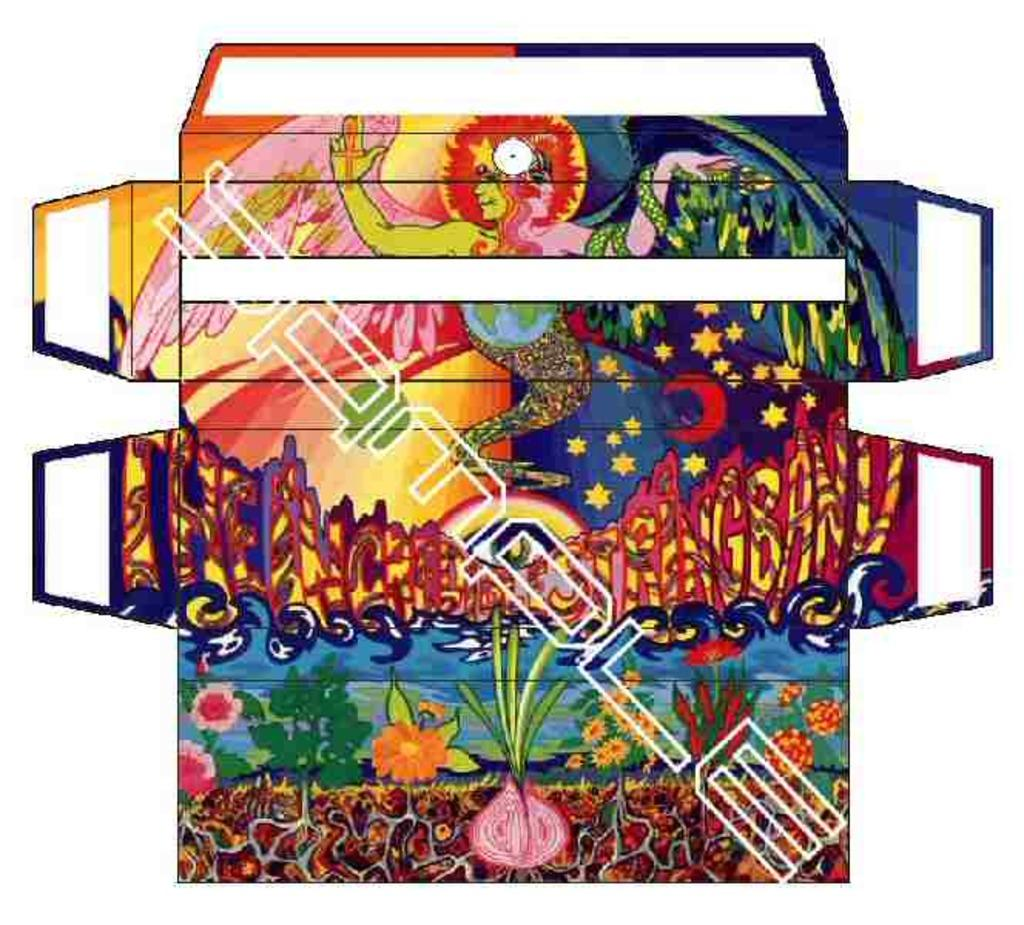What is the main object in the image? There is a board in the image. What can be seen on the board? The board has flowers in pink, orange, and red colors. What other object is present in the image? There is an onion in the image. What celestial objects are visible in the image? There are stars and a moon visible in the image. What type of river can be seen flowing through the image? There is no river present in the image. Can you describe the kettle used for boiling water in the image? There is no kettle visible in the image. 